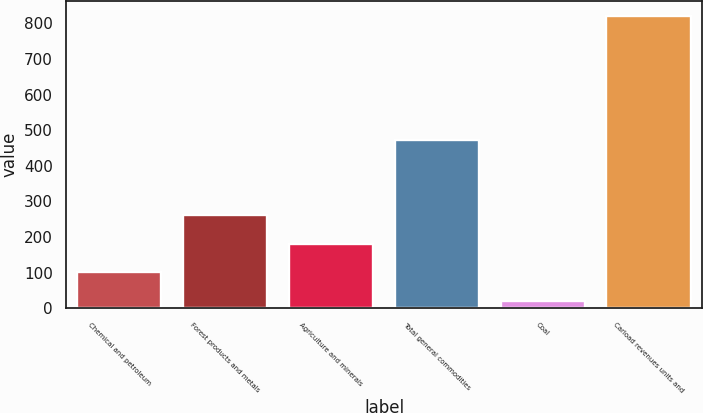Convert chart to OTSL. <chart><loc_0><loc_0><loc_500><loc_500><bar_chart><fcel>Chemical and petroleum<fcel>Forest products and metals<fcel>Agriculture and minerals<fcel>Total general commodities<fcel>Coal<fcel>Carload revenues units and<nl><fcel>101.2<fcel>261.2<fcel>181.2<fcel>471.5<fcel>21.2<fcel>821.2<nl></chart> 